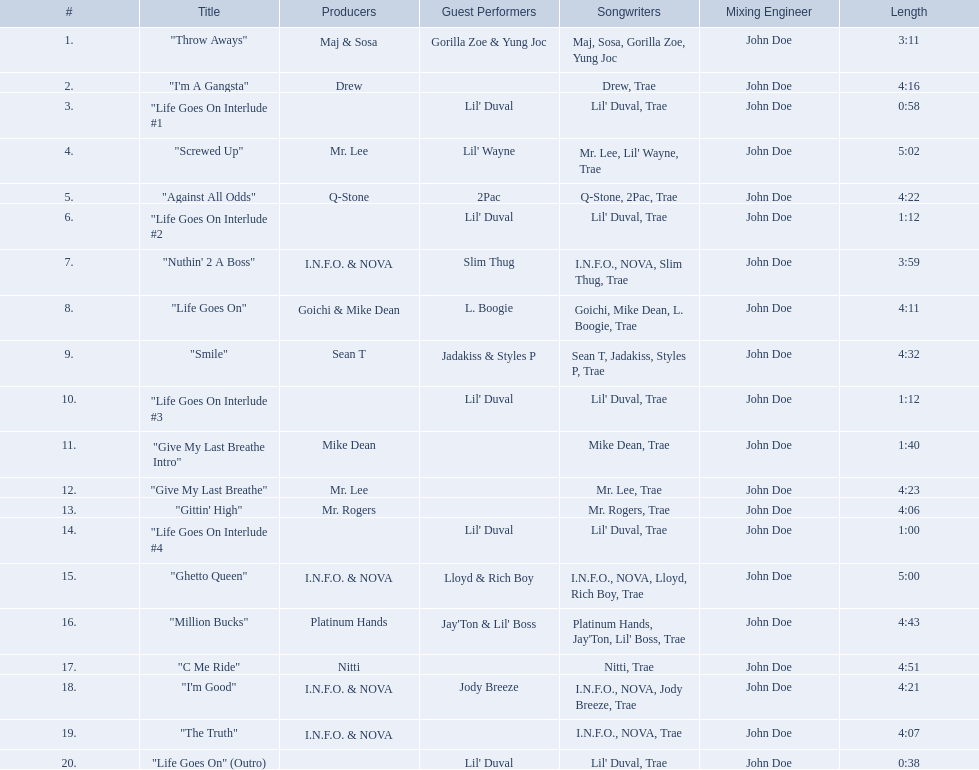What tracks appear on the album life goes on (trae album)? "Throw Aways", "I'm A Gangsta", "Life Goes On Interlude #1, "Screwed Up", "Against All Odds", "Life Goes On Interlude #2, "Nuthin' 2 A Boss", "Life Goes On", "Smile", "Life Goes On Interlude #3, "Give My Last Breathe Intro", "Give My Last Breathe", "Gittin' High", "Life Goes On Interlude #4, "Ghetto Queen", "Million Bucks", "C Me Ride", "I'm Good", "The Truth", "Life Goes On" (Outro). Which of these songs are at least 5 minutes long? "Screwed Up", "Ghetto Queen". Of these two songs over 5 minutes long, which is longer? "Screwed Up". How long is this track? 5:02. 